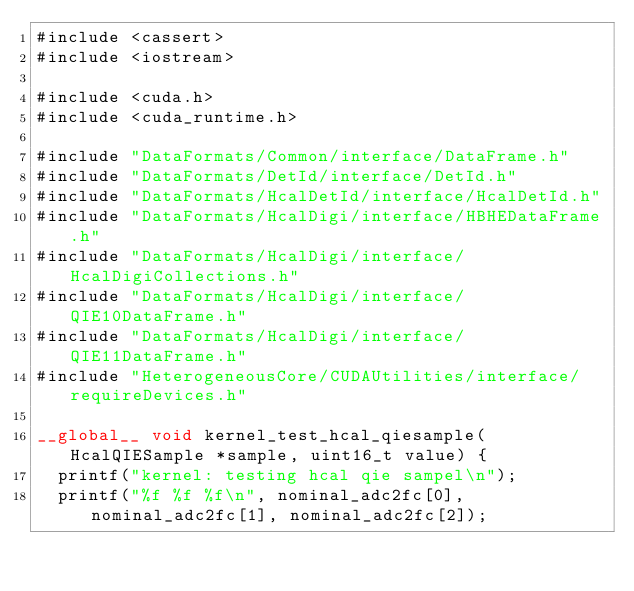Convert code to text. <code><loc_0><loc_0><loc_500><loc_500><_Cuda_>#include <cassert>
#include <iostream>

#include <cuda.h>
#include <cuda_runtime.h>

#include "DataFormats/Common/interface/DataFrame.h"
#include "DataFormats/DetId/interface/DetId.h"
#include "DataFormats/HcalDetId/interface/HcalDetId.h"
#include "DataFormats/HcalDigi/interface/HBHEDataFrame.h"
#include "DataFormats/HcalDigi/interface/HcalDigiCollections.h"
#include "DataFormats/HcalDigi/interface/QIE10DataFrame.h"
#include "DataFormats/HcalDigi/interface/QIE11DataFrame.h"
#include "HeterogeneousCore/CUDAUtilities/interface/requireDevices.h"

__global__ void kernel_test_hcal_qiesample(HcalQIESample *sample, uint16_t value) {
  printf("kernel: testing hcal qie sampel\n");
  printf("%f %f %f\n", nominal_adc2fc[0], nominal_adc2fc[1], nominal_adc2fc[2]);
</code> 